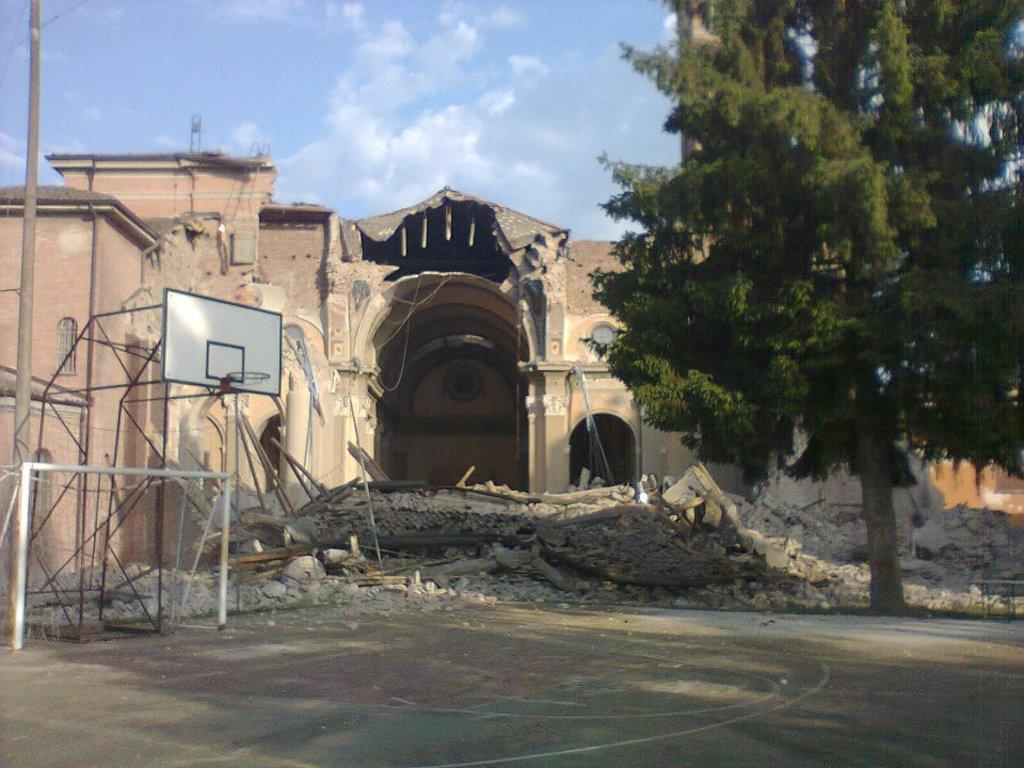What is happening to the building in the image? The building is under excavation in the image. What type of recreational area can be seen in the image? There is a basketball court in the image. What type of vegetation is present in the image? There are trees in the image. What structures are present in the image besides the building and basketball court? There are poles in the image. What can be seen in the background of the image? The sky with clouds is visible in the background of the image. What type of prose is being written on the basketball court in the image? There is no prose being written on the basketball court in the image; it is a recreational area for playing basketball. How many fingers can be seen holding the calculator in the image? There is no calculator or fingers present in the image. 